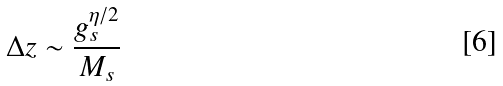Convert formula to latex. <formula><loc_0><loc_0><loc_500><loc_500>\Delta z \sim \frac { g _ { s } ^ { \eta / 2 } } { M _ { s } }</formula> 